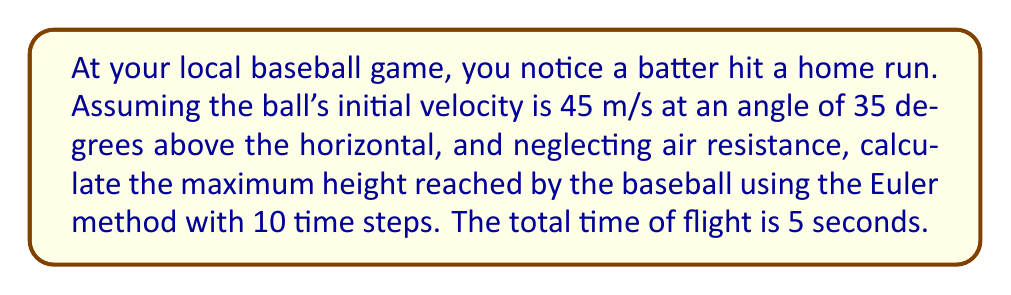Solve this math problem. To solve this problem using the Euler method, we'll follow these steps:

1) First, let's define our variables:
   $v_0 = 45$ m/s (initial velocity)
   $\theta = 35°$ (launch angle)
   $g = 9.8$ m/s² (acceleration due to gravity)
   $t_{total} = 5$ s (total time of flight)
   $n = 10$ (number of time steps)

2) Calculate the time step size:
   $$\Delta t = \frac{t_{total}}{n} = \frac{5}{10} = 0.5\text{ s}$$

3) Break down the initial velocity into x and y components:
   $$v_{0x} = v_0 \cos(\theta) = 45 \cos(35°) = 36.87\text{ m/s}$$
   $$v_{0y} = v_0 \sin(\theta) = 45 \sin(35°) = 25.80\text{ m/s}$$

4) Set up initial conditions:
   $t_0 = 0\text{ s}$, $y_0 = 0\text{ m}$, $v_{y0} = 25.80\text{ m/s}$

5) Apply the Euler method:
   For each time step $i$ from 1 to 10:
   $$t_i = t_{i-1} + \Delta t$$
   $$v_{yi} = v_{y(i-1)} - g\Delta t$$
   $$y_i = y_{i-1} + v_{y(i-1)}\Delta t$$

6) Calculate for each step:
   Step 1: $t_1 = 0.5\text{ s}$, $v_{y1} = 20.90\text{ m/s}$, $y_1 = 12.90\text{ m}$
   Step 2: $t_2 = 1.0\text{ s}$, $v_{y2} = 16.00\text{ m/s}$, $y_2 = 23.35\text{ m}$
   Step 3: $t_3 = 1.5\text{ s}$, $v_{y3} = 11.10\text{ m/s}$, $y_3 = 31.35\text{ m}$
   Step 4: $t_4 = 2.0\text{ s}$, $v_{y4} = 6.20\text{ m/s}$, $y_4 = 36.90\text{ m}$
   Step 5: $t_5 = 2.5\text{ s}$, $v_{y5} = 1.30\text{ m/s}$, $y_5 = 40.00\text{ m}$
   Step 6: $t_6 = 3.0\text{ s}$, $v_{y6} = -3.60\text{ m/s}$, $y_6 = 40.65\text{ m}$
   Step 7: $t_7 = 3.5\text{ s}$, $v_{y7} = -8.50\text{ m/s}$, $y_7 = 38.85\text{ m}$
   Step 8: $t_8 = 4.0\text{ s}$, $v_{y8} = -13.40\text{ m/s}$, $y_8 = 34.60\text{ m}$
   Step 9: $t_9 = 4.5\text{ s}$, $v_{y9} = -18.30\text{ m/s}$, $y_9 = 27.90\text{ m}$
   Step 10: $t_{10} = 5.0\text{ s}$, $v_{y10} = -23.20\text{ m/s}$, $y_{10} = 18.75\text{ m}$

7) The maximum height is the largest y value, which occurs at step 6.
Answer: The maximum height reached by the baseball, calculated using the Euler method with 10 time steps, is approximately 40.65 m. 